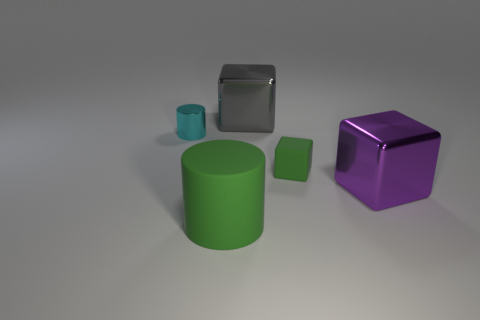Is the green cylinder made of the same material as the tiny object that is left of the matte cube?
Keep it short and to the point. No. Are there more gray things behind the big gray block than matte blocks?
Your answer should be compact. No. Is there any other thing that is the same size as the purple metallic thing?
Your answer should be compact. Yes. Do the tiny block and the big shiny cube in front of the green matte block have the same color?
Give a very brief answer. No. Is the number of shiny things behind the purple object the same as the number of big purple metallic cubes that are on the left side of the cyan metal object?
Your response must be concise. No. What is the large block that is behind the small cyan cylinder made of?
Provide a succinct answer. Metal. What number of things are either metal cylinders behind the small matte cube or cyan metallic things?
Provide a short and direct response. 1. What number of other things are the same shape as the purple metal object?
Make the answer very short. 2. Do the object that is in front of the large purple shiny cube and the cyan object have the same shape?
Give a very brief answer. Yes. Are there any big purple metal objects behind the large purple cube?
Your answer should be very brief. No. 